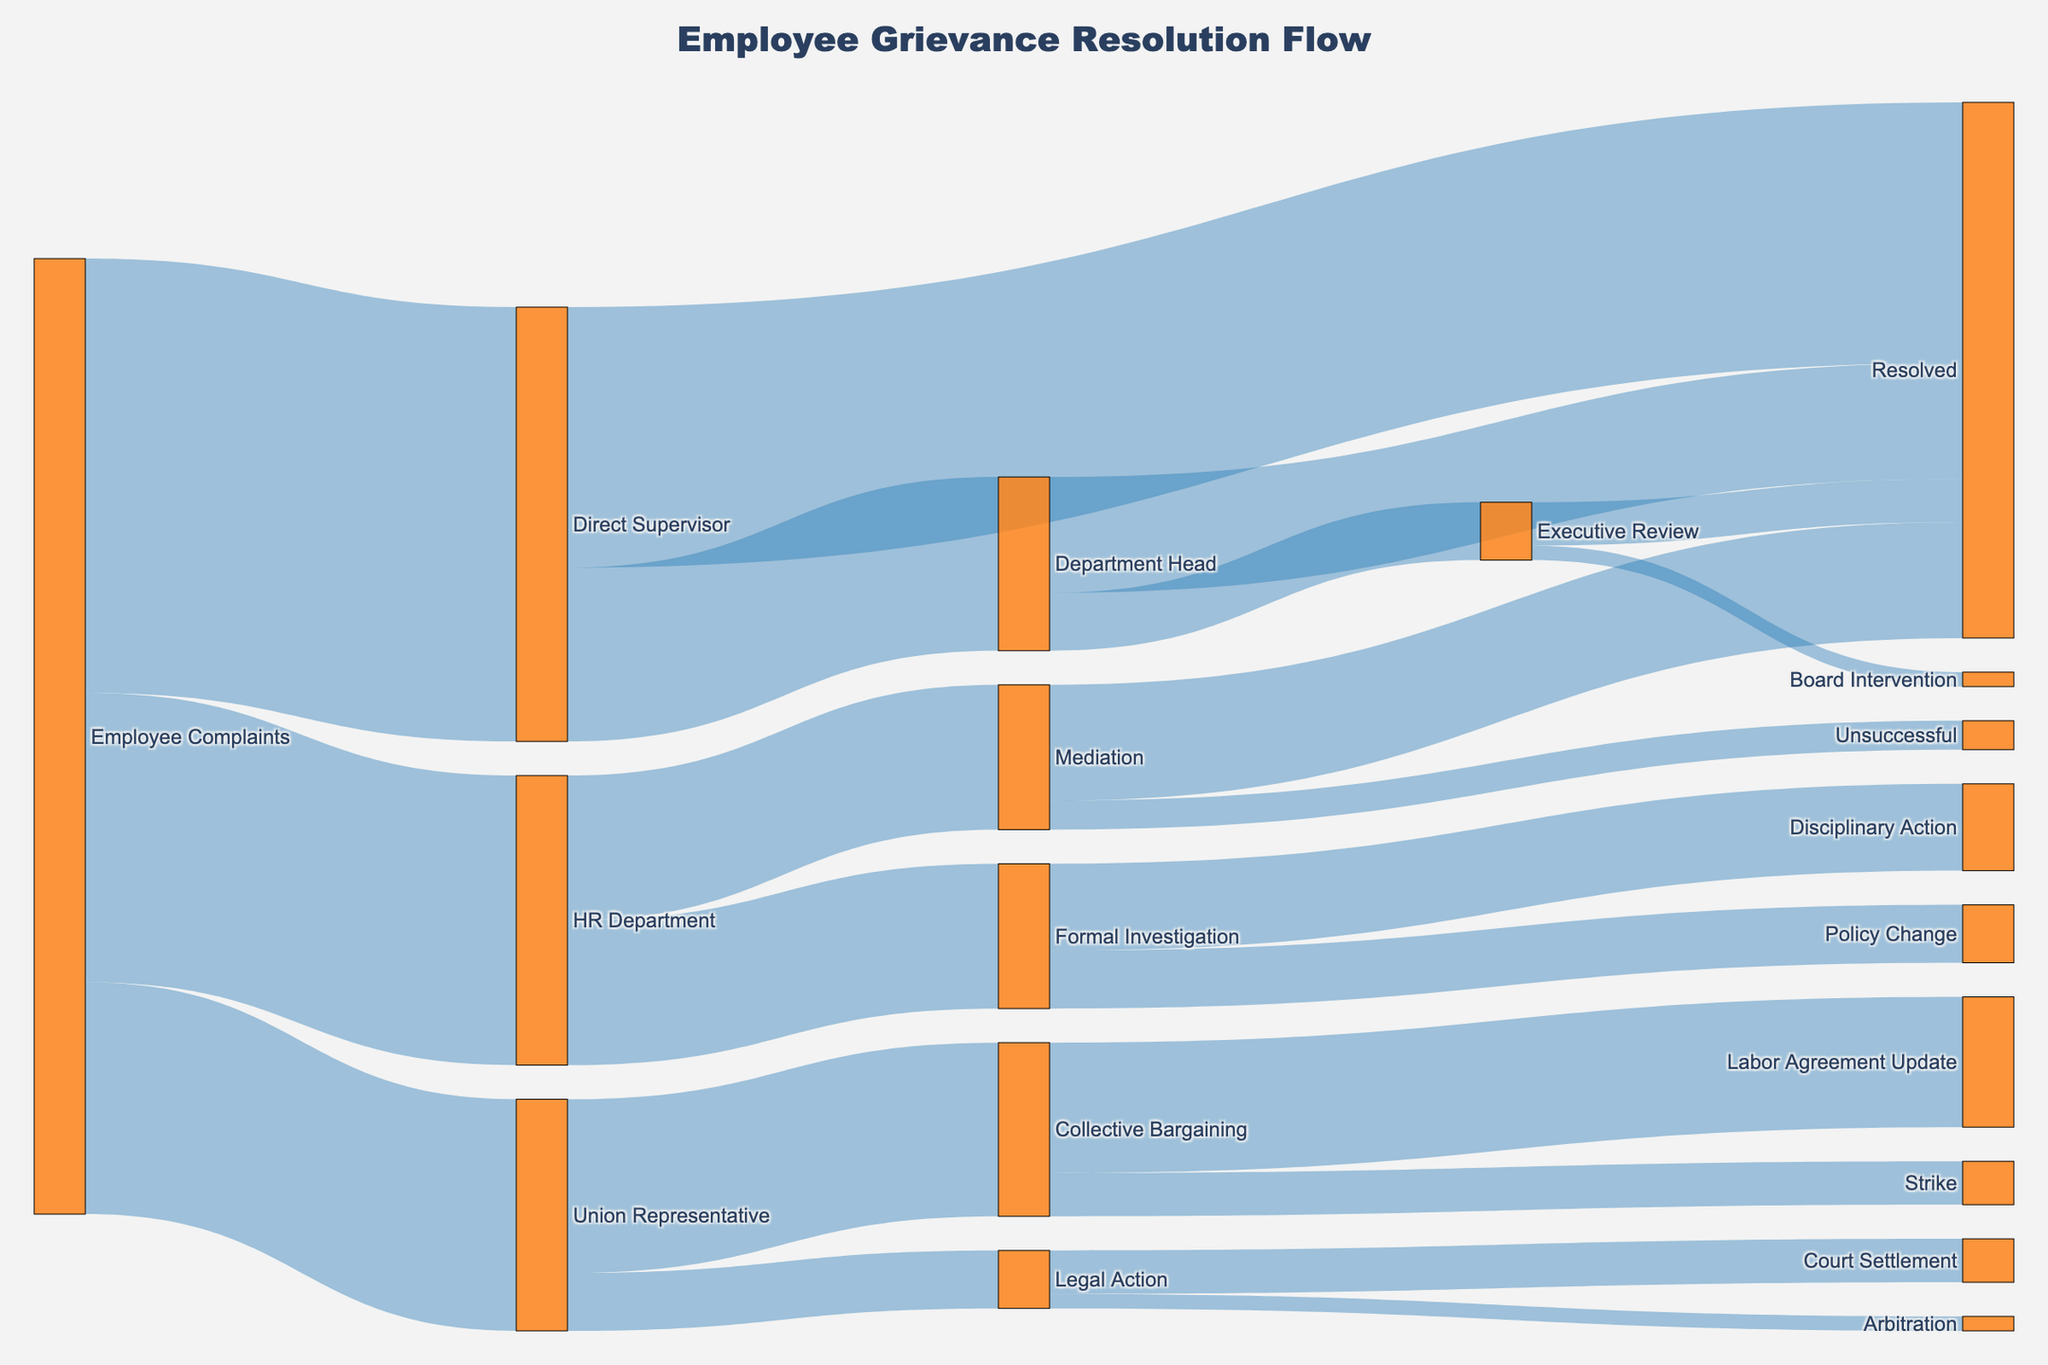What is the title of the Sankey diagram? The title of the figure is shown at the top and provides a clear summary of what the diagram represents. The text size is larger than the rest of the text in the figure.
Answer: Employee Grievance Resolution Flow How many complaints were initially directed to the HR Department? Look at the flow from 'Employee Complaints' to 'HR Department' and note the corresponding value.
Answer: 100 Which resolution channel received the most complaints directly from employees? Compare the values of flows from 'Employee Complaints' to different targets: 'Direct Supervisor', 'HR Department', and 'Union Representative'. The highest value will reveal the answer.
Answer: Direct Supervisor How many complaints were resolved at the level of the Direct Supervisor? Identify the flow from 'Direct Supervisor' to 'Resolved' and note the value associated with that flow.
Answer: 90 What is the total number of grievances processed by the Union Representative? Sum the values of the flows from 'Employee Complaints' to 'Union Representative', and the subsequent flows from 'Union Representative' to 'Collective Bargaining' and 'Legal Action'.
Answer: 80 What channel leads to the most successful resolutions? Compare the flows leading to 'Resolved' from different sources: 'Direct Supervisor', 'Department Head', and 'Mediation'. The source with the highest value directed to 'Resolved' indicates the most successful channel.
Answer: Direct Supervisor Which channel has the least number of unresolved grievances? Compare the values of flows leading to non-successful outcomes from sources like 'Direct Supervisor', 'HR Department', 'Union Representative', etc., and identify the channel with the lowest number of grievances.
Answer: Mediation What is the difference between complaints resolved by the Direct Supervisor and those escalated to the Department Head? Find the values of complaints resolved by the 'Direct Supervisor' (90) and those escalated to the 'Department Head' (60), then subtract the latter from the former.
Answer: 30 How many grievances reached the Board Intervention stage? Identify the flow from 'Executive Review' to 'Board Intervention' and note the value.
Answer: 5 Which path ends up in Disciplinary Action? Trace the flow leading to 'Disciplinary Action' and identify the starting point.
Answer: Formal Investigation 